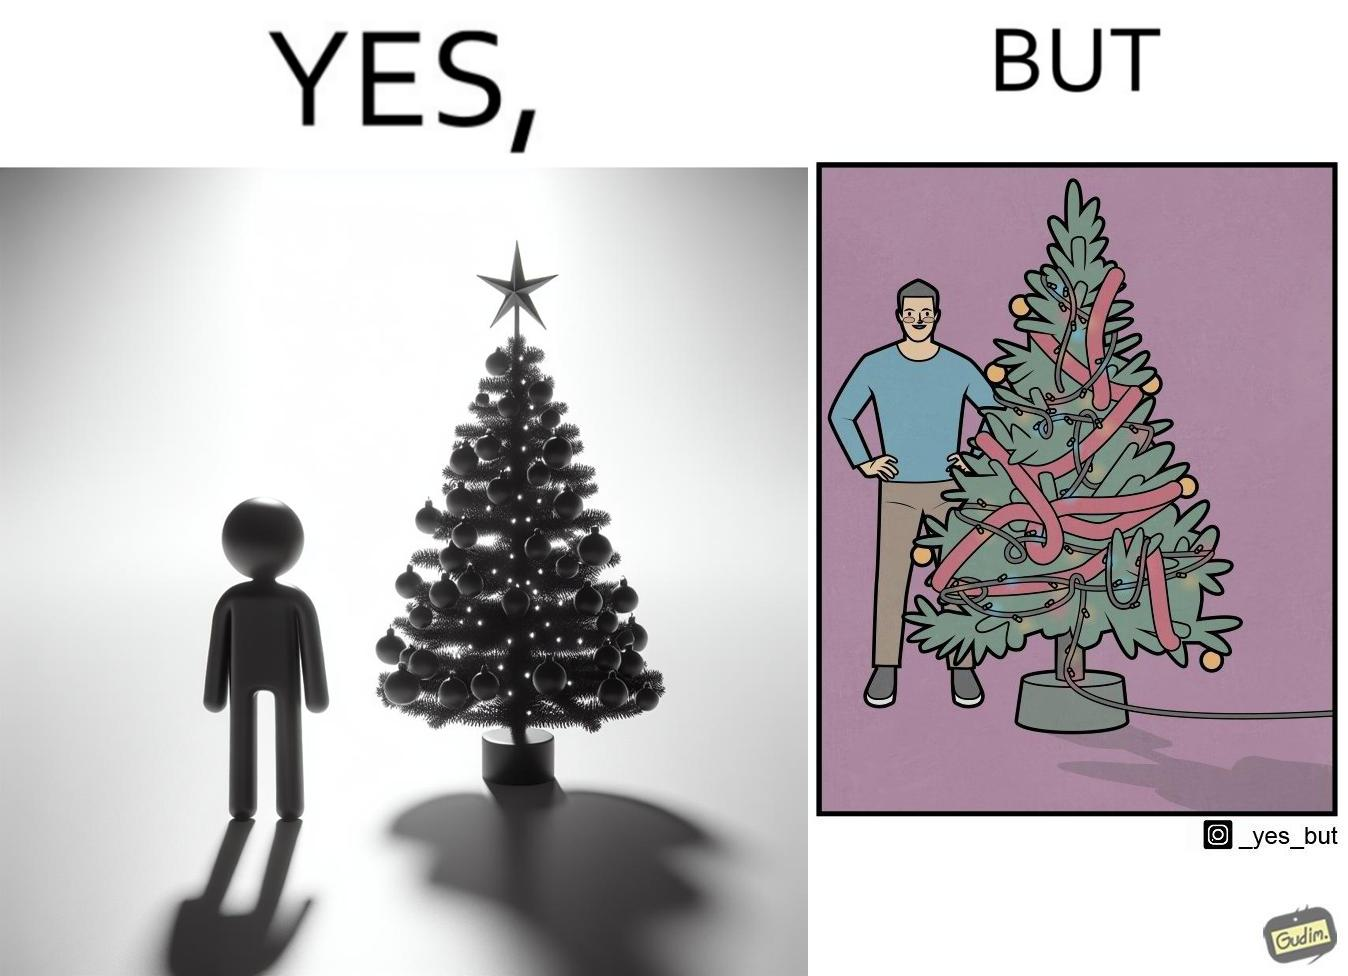Describe the contrast between the left and right parts of this image. In the left part of the image: a person looking at a X-mas tree In the right part of the image: a person looking at a X-mas tree on which various bulbs are put and are connected to electricity source 